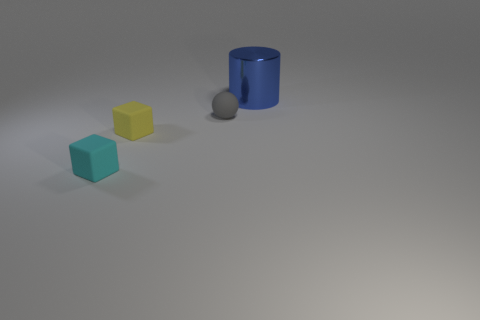Is there any other thing that is the same material as the big cylinder?
Offer a terse response. No. What material is the cyan cube that is the same size as the gray thing?
Your answer should be compact. Rubber. There is a object that is to the left of the yellow matte object; is its size the same as the large shiny thing?
Your answer should be compact. No. There is a matte object that is left of the small yellow matte object; is it the same shape as the yellow rubber object?
Give a very brief answer. Yes. What number of objects are either cylinders or tiny objects that are left of the gray rubber ball?
Provide a short and direct response. 3. Is the number of small cyan blocks less than the number of large metal blocks?
Make the answer very short. No. Are there more red cylinders than big blue cylinders?
Make the answer very short. No. How many other objects are there of the same material as the tiny sphere?
Offer a very short reply. 2. There is a block in front of the cube that is to the right of the cyan object; what number of large blue cylinders are in front of it?
Make the answer very short. 0. What number of rubber objects are either spheres or big blue cylinders?
Your response must be concise. 1. 